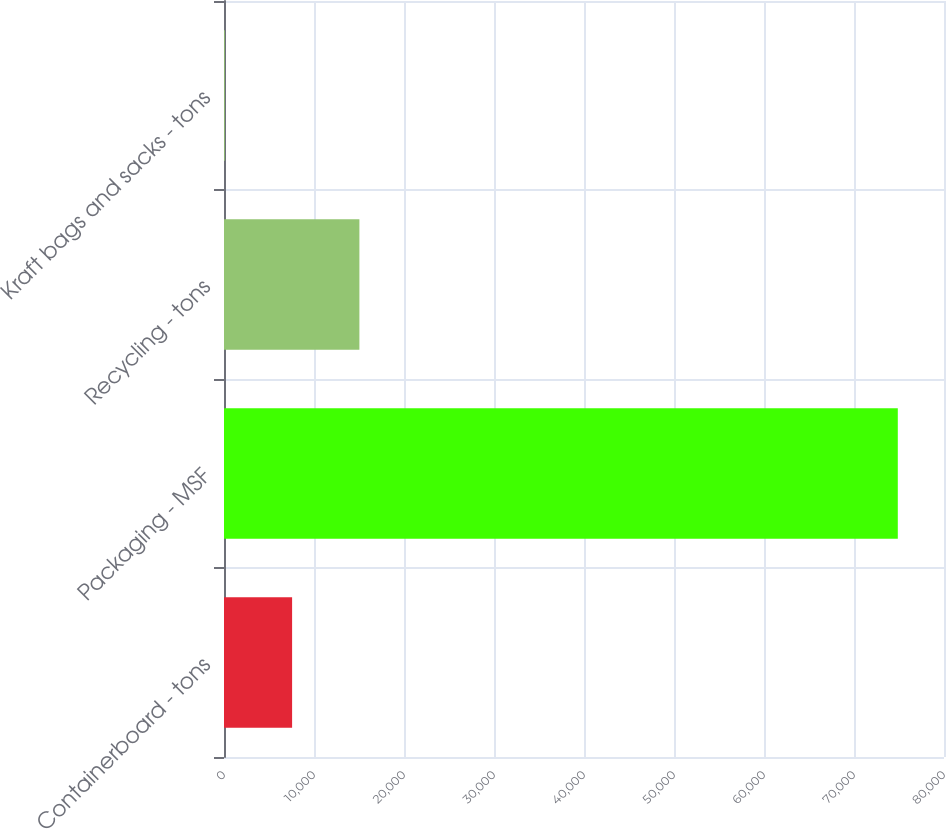Convert chart. <chart><loc_0><loc_0><loc_500><loc_500><bar_chart><fcel>Containerboard - tons<fcel>Packaging - MSF<fcel>Recycling - tons<fcel>Kraft bags and sacks - tons<nl><fcel>7566.8<fcel>74867<fcel>15044.6<fcel>89<nl></chart> 